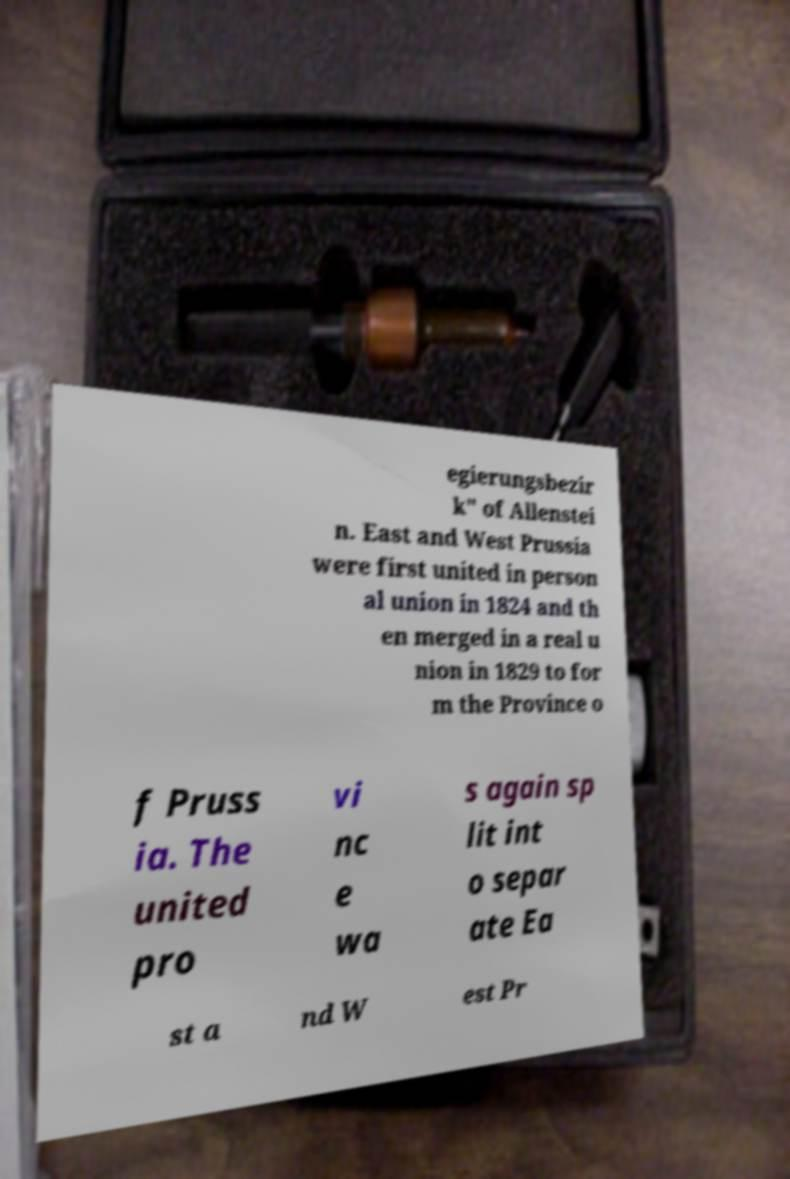There's text embedded in this image that I need extracted. Can you transcribe it verbatim? egierungsbezir k" of Allenstei n. East and West Prussia were first united in person al union in 1824 and th en merged in a real u nion in 1829 to for m the Province o f Pruss ia. The united pro vi nc e wa s again sp lit int o separ ate Ea st a nd W est Pr 